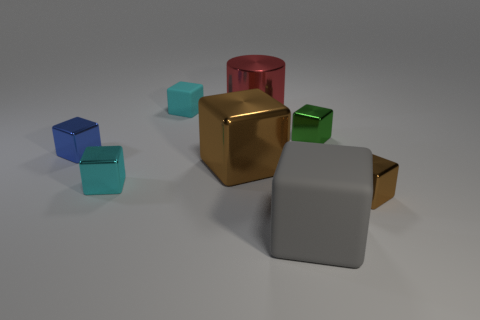Subtract 2 cubes. How many cubes are left? 5 Subtract all cyan blocks. How many blocks are left? 5 Subtract all gray matte cubes. How many cubes are left? 6 Subtract all purple blocks. Subtract all brown spheres. How many blocks are left? 7 Add 2 red metallic blocks. How many objects exist? 10 Subtract all blocks. How many objects are left? 1 Add 7 tiny gray metallic cylinders. How many tiny gray metallic cylinders exist? 7 Subtract 0 blue balls. How many objects are left? 8 Subtract all cyan rubber cubes. Subtract all tiny gray spheres. How many objects are left? 7 Add 8 large gray objects. How many large gray objects are left? 9 